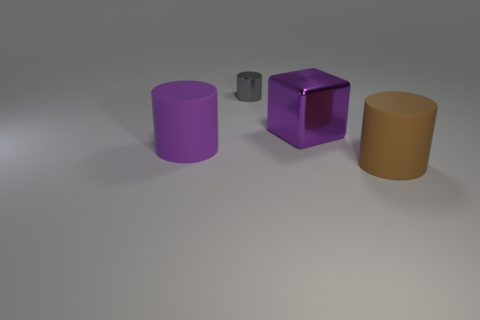There is a large metallic cube; are there any purple objects on the left side of it?
Provide a short and direct response. Yes. Are there any other things that are the same color as the big metal thing?
Keep it short and to the point. Yes. How many cylinders are tiny gray things or big purple metallic objects?
Provide a short and direct response. 1. How many cylinders are behind the brown rubber cylinder and in front of the tiny gray cylinder?
Your response must be concise. 1. Are there the same number of small gray cylinders that are right of the big brown rubber cylinder and large brown things that are behind the big cube?
Offer a very short reply. Yes. Is the shape of the purple object on the left side of the purple metallic object the same as  the tiny gray thing?
Provide a short and direct response. Yes. The large rubber object that is right of the purple thing that is behind the large matte cylinder that is on the left side of the small metallic cylinder is what shape?
Offer a very short reply. Cylinder. What is the shape of the matte object that is the same color as the shiny cube?
Your answer should be compact. Cylinder. The object that is both behind the large purple matte thing and left of the large purple metal block is made of what material?
Your answer should be compact. Metal. Are there fewer purple objects than big objects?
Keep it short and to the point. Yes. 